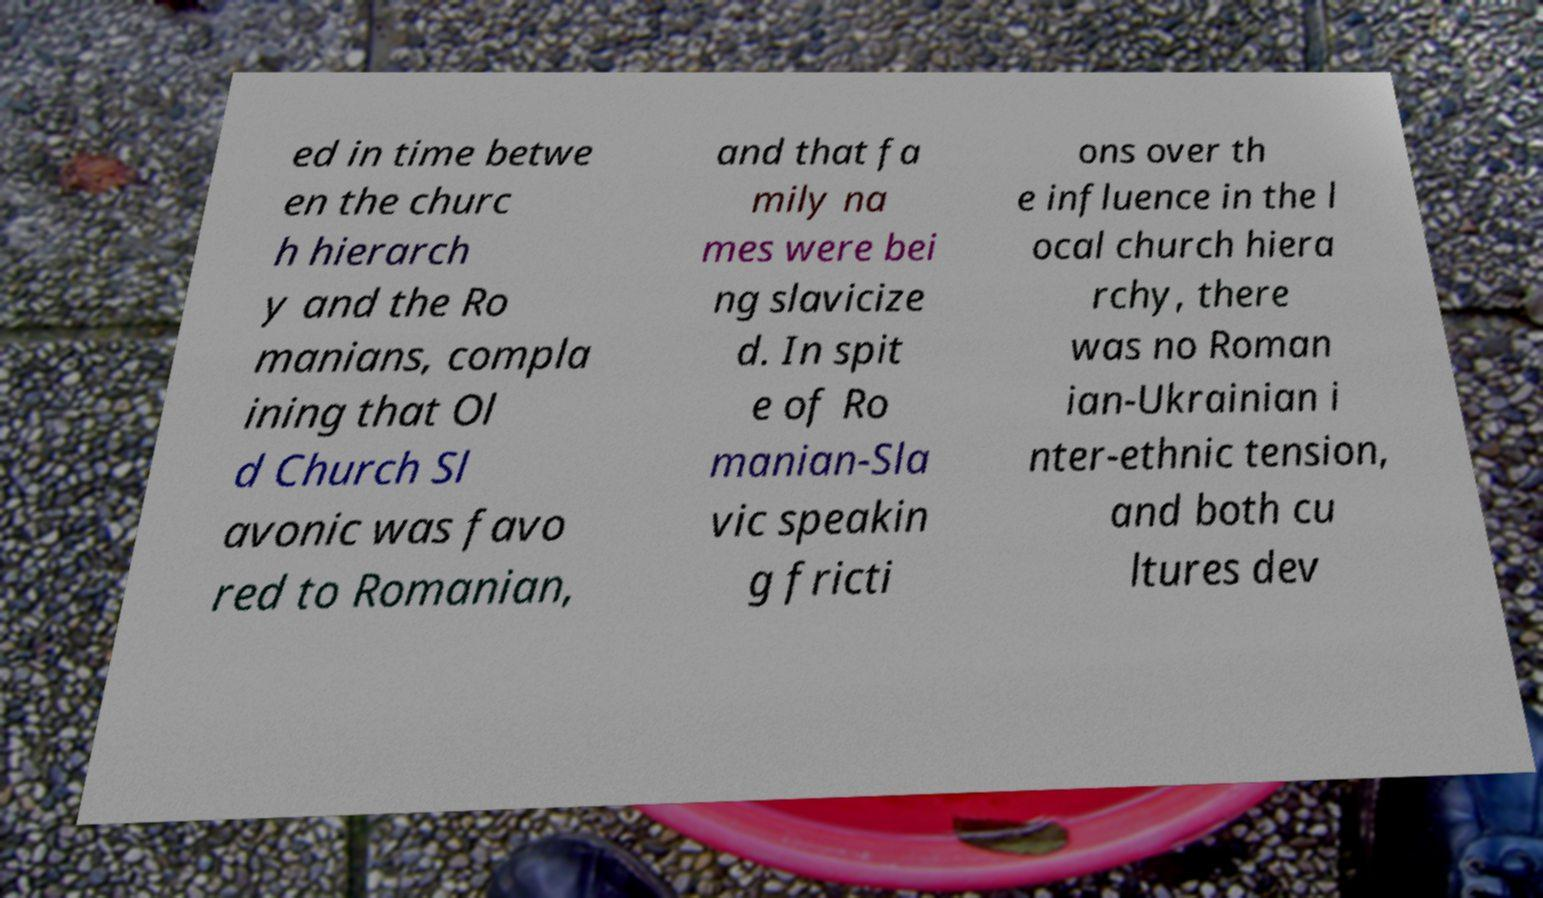Please identify and transcribe the text found in this image. ed in time betwe en the churc h hierarch y and the Ro manians, compla ining that Ol d Church Sl avonic was favo red to Romanian, and that fa mily na mes were bei ng slavicize d. In spit e of Ro manian-Sla vic speakin g fricti ons over th e influence in the l ocal church hiera rchy, there was no Roman ian-Ukrainian i nter-ethnic tension, and both cu ltures dev 